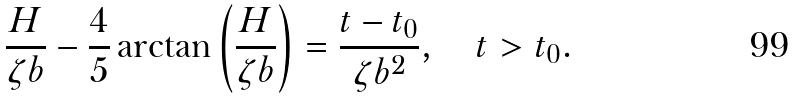<formula> <loc_0><loc_0><loc_500><loc_500>\frac { H } { \zeta b } - \frac { 4 } { 5 } \arctan \left ( \frac { H } { \zeta b } \right ) = \frac { t - t _ { 0 } } { \zeta b ^ { 2 } } , \quad t > t _ { 0 } .</formula> 